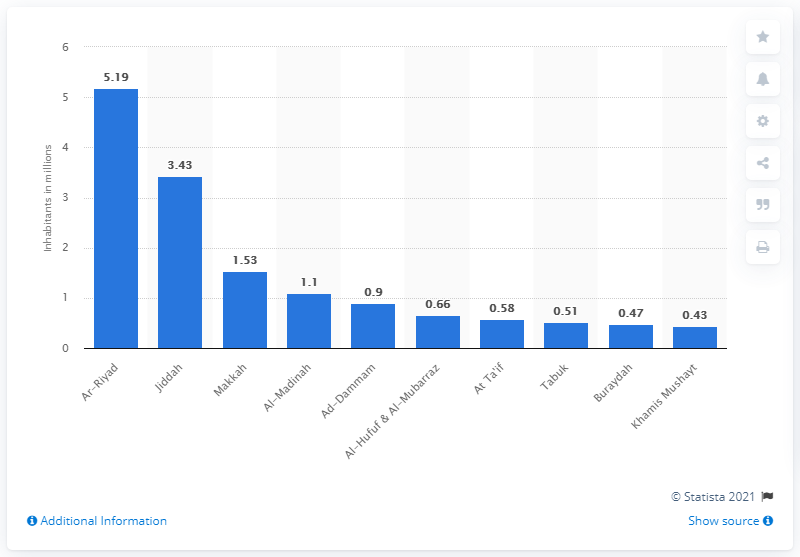Specify some key components in this picture. According to data from 2010, the number of people living in Rhiad was approximately 5.19 million. 